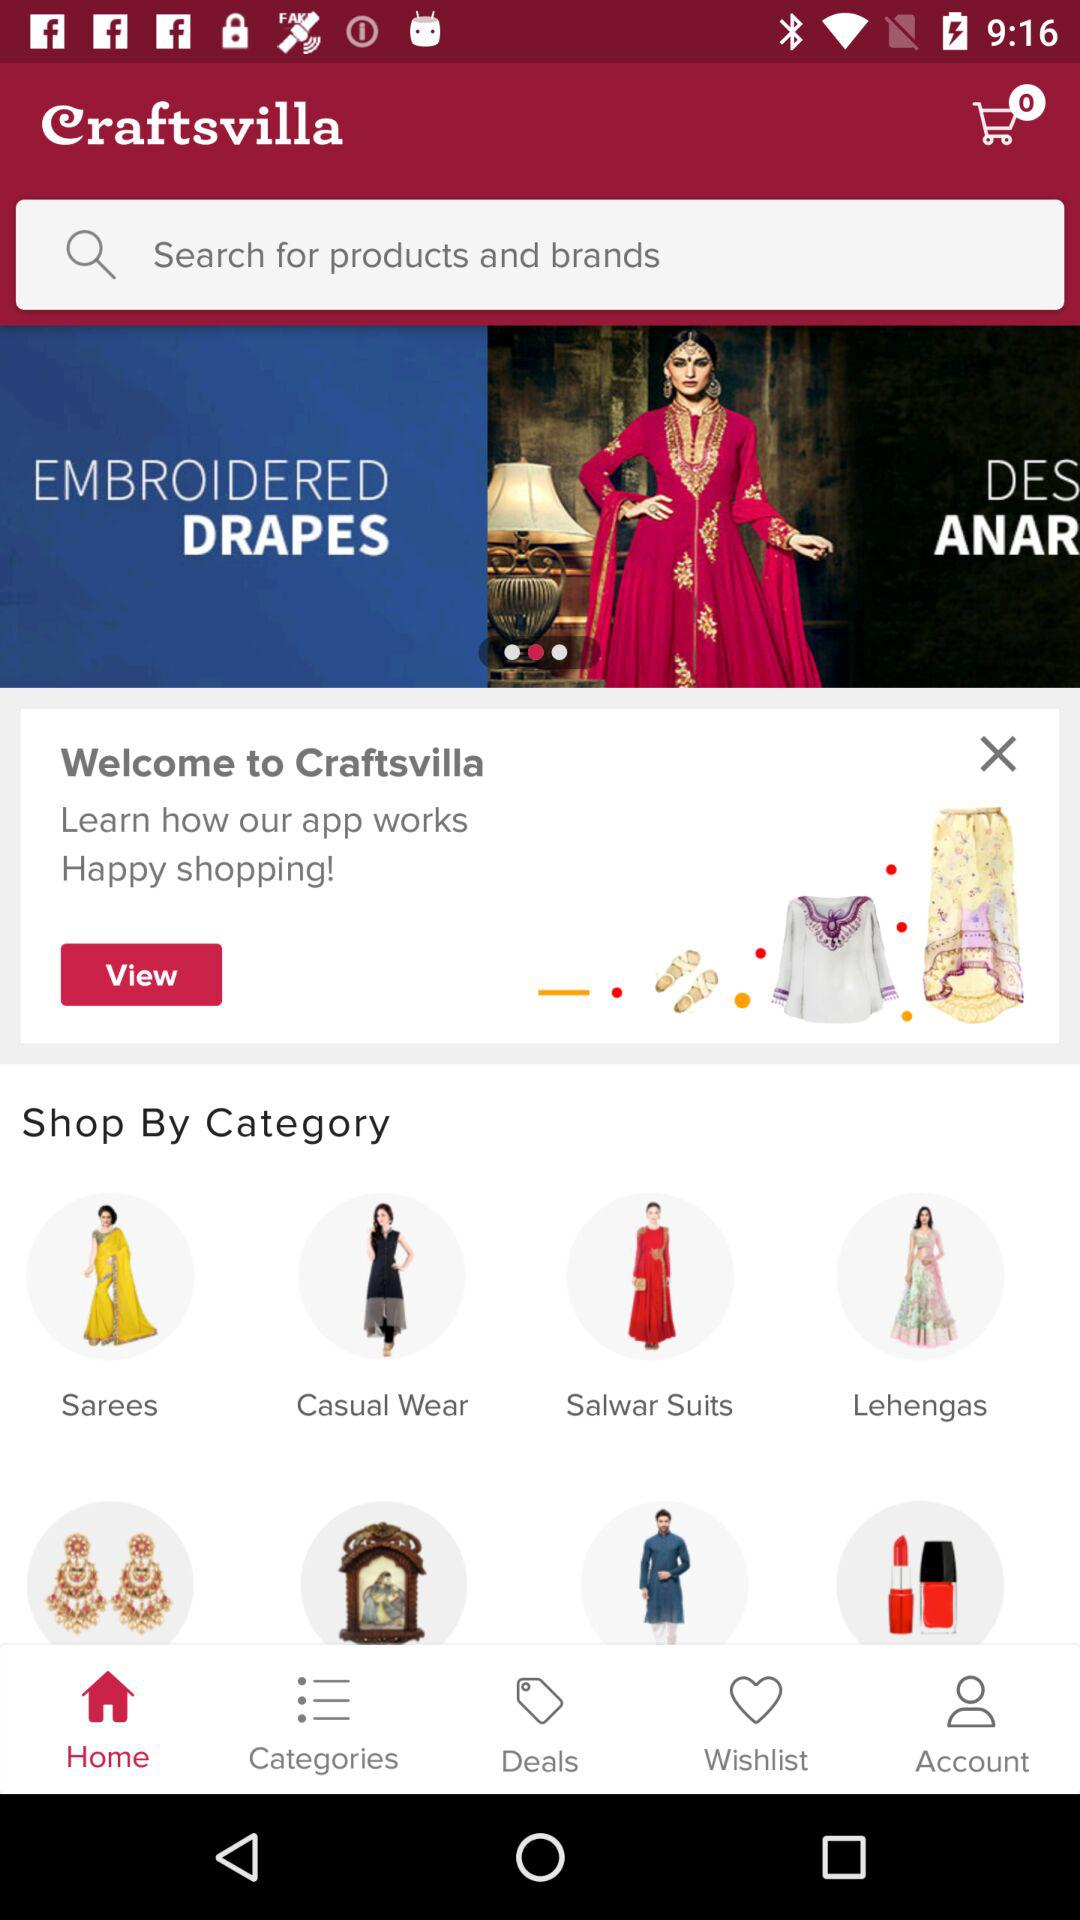Which tab is selected? The selected tab is "Home". 